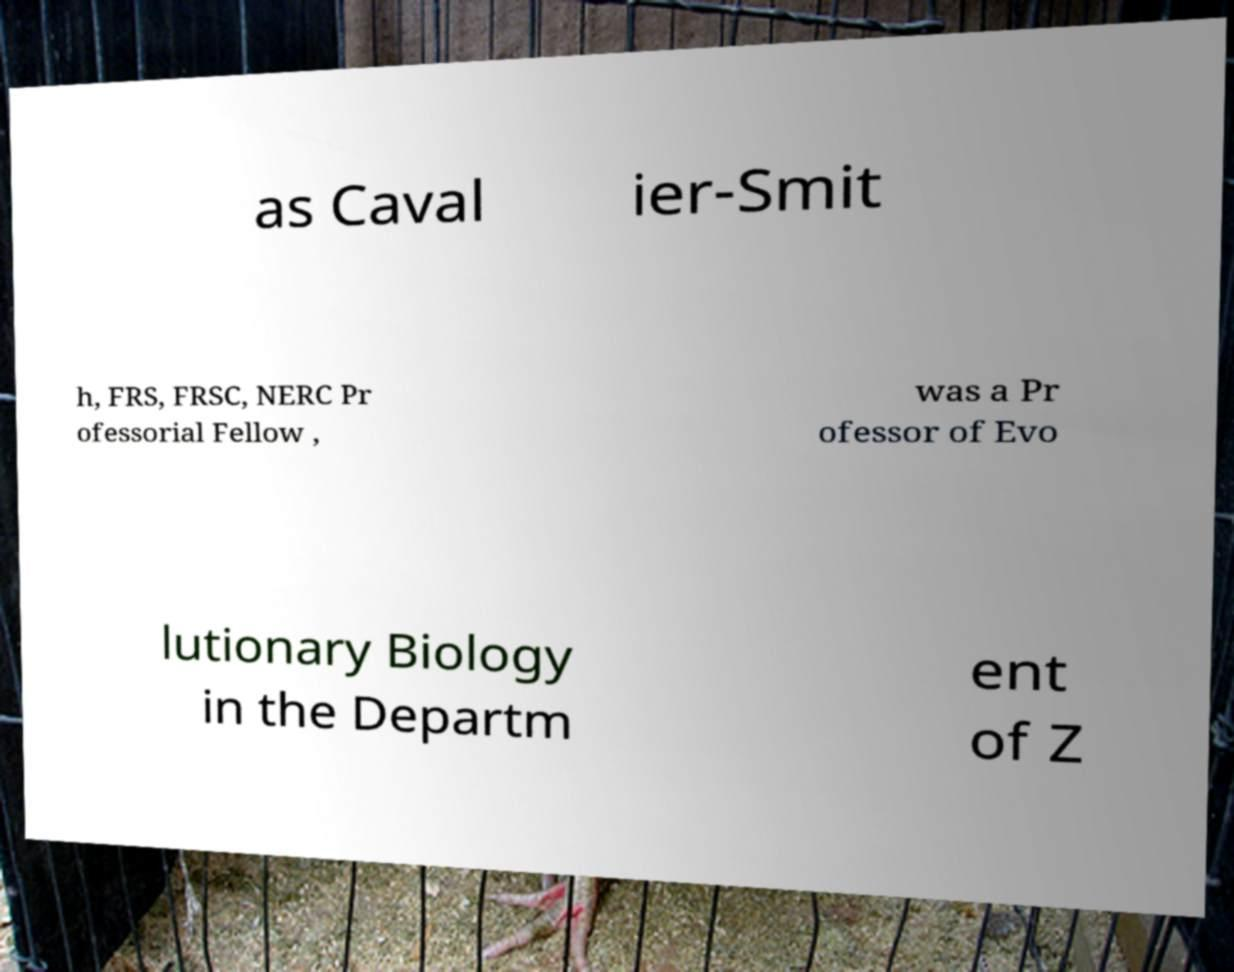Can you accurately transcribe the text from the provided image for me? as Caval ier-Smit h, FRS, FRSC, NERC Pr ofessorial Fellow , was a Pr ofessor of Evo lutionary Biology in the Departm ent of Z 